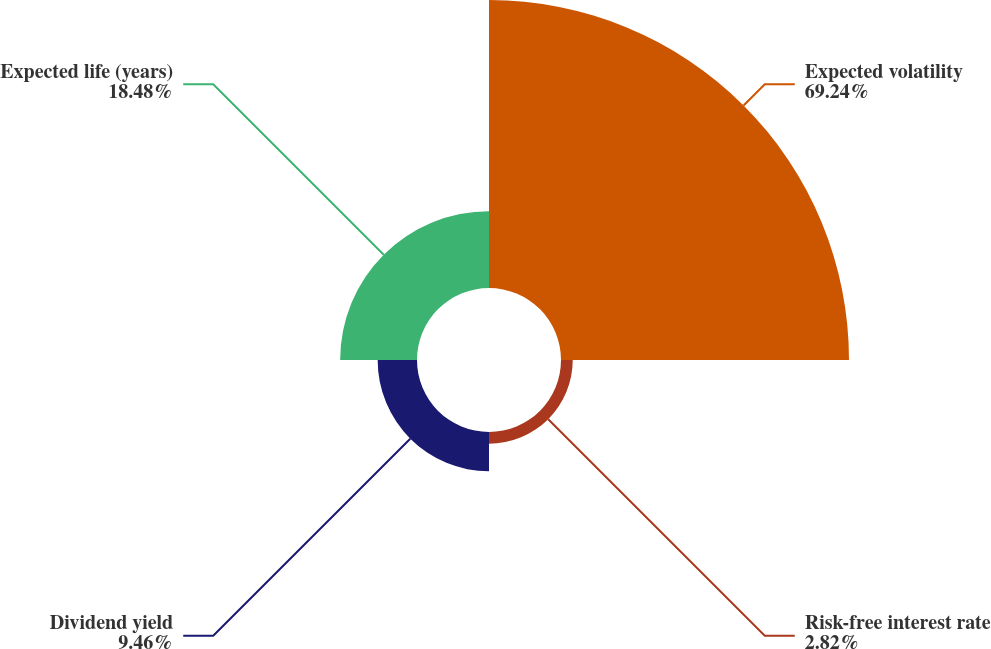Convert chart. <chart><loc_0><loc_0><loc_500><loc_500><pie_chart><fcel>Expected volatility<fcel>Risk-free interest rate<fcel>Dividend yield<fcel>Expected life (years)<nl><fcel>69.24%<fcel>2.82%<fcel>9.46%<fcel>18.48%<nl></chart> 